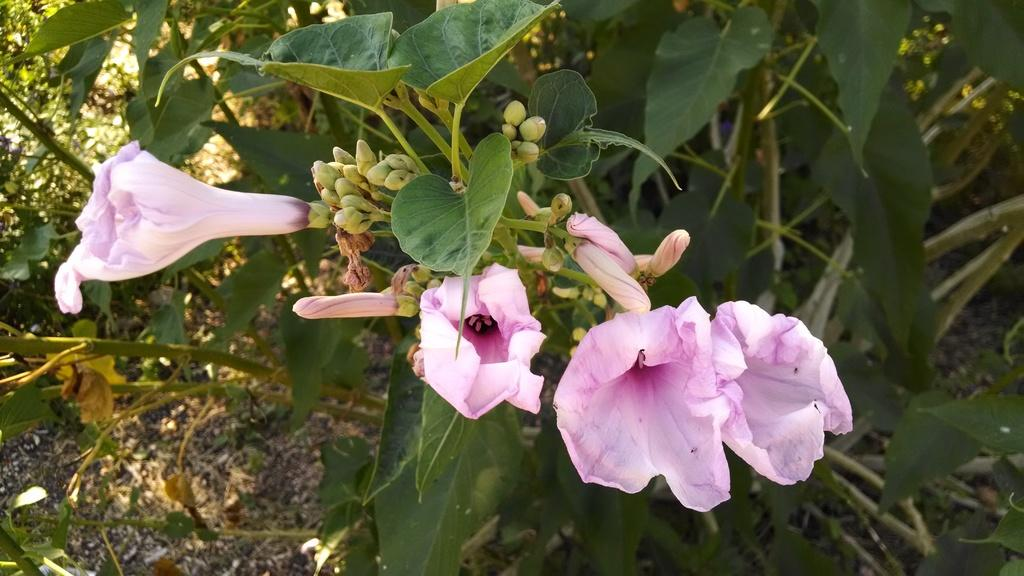What type of living organisms can be seen in the image? Flowers and plants can be seen in the image. Can you describe the plants in the image? The plants in the image are not specified, but they are present alongside the flowers. How many jellyfish can be seen swimming in the image? There are no jellyfish present in the image; it features flowers and plants. What type of toy is visible in the image? There is no toy present in the image. 